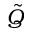<formula> <loc_0><loc_0><loc_500><loc_500>\tilde { Q }</formula> 